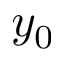<formula> <loc_0><loc_0><loc_500><loc_500>y _ { 0 }</formula> 